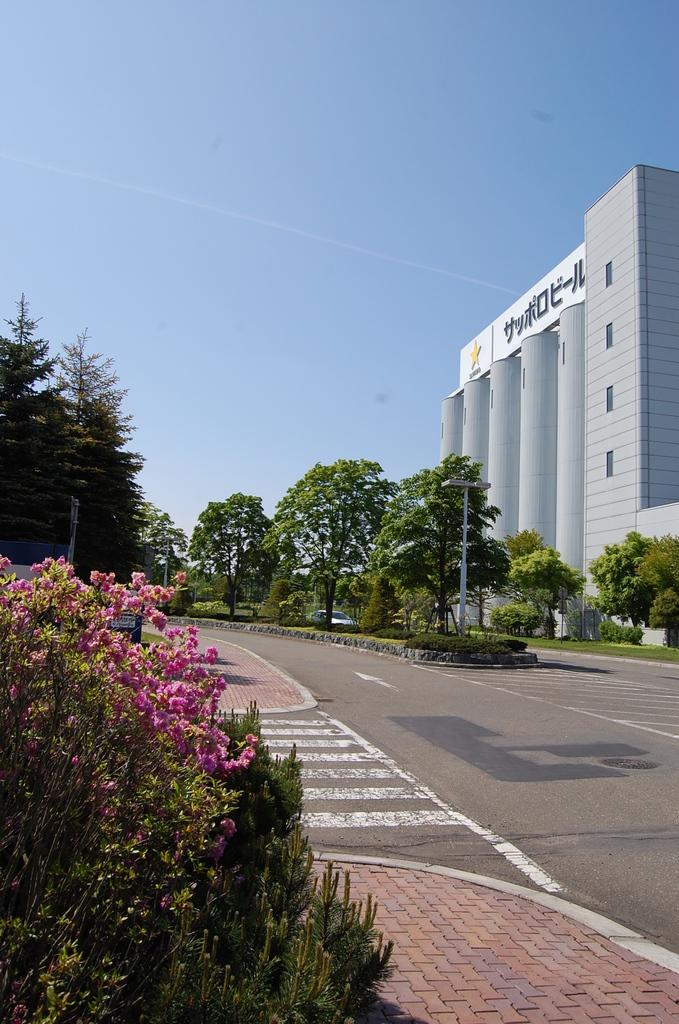What types of living organisms can be seen in the image? Plants and flowers are visible in the image. What is the primary mode of transportation in the image? There is a car on the road in the image. What architectural features can be seen in the image? There are poles and a building in the image. What type of vegetation is present in the image? Trees are present in the image. What part of the natural environment is visible in the image? The sky is visible in the background of the image. Can you see any elbows in the image? There are no elbows present in the image. Are there any cobwebs visible in the image? There are no cobwebs visible in the image. 